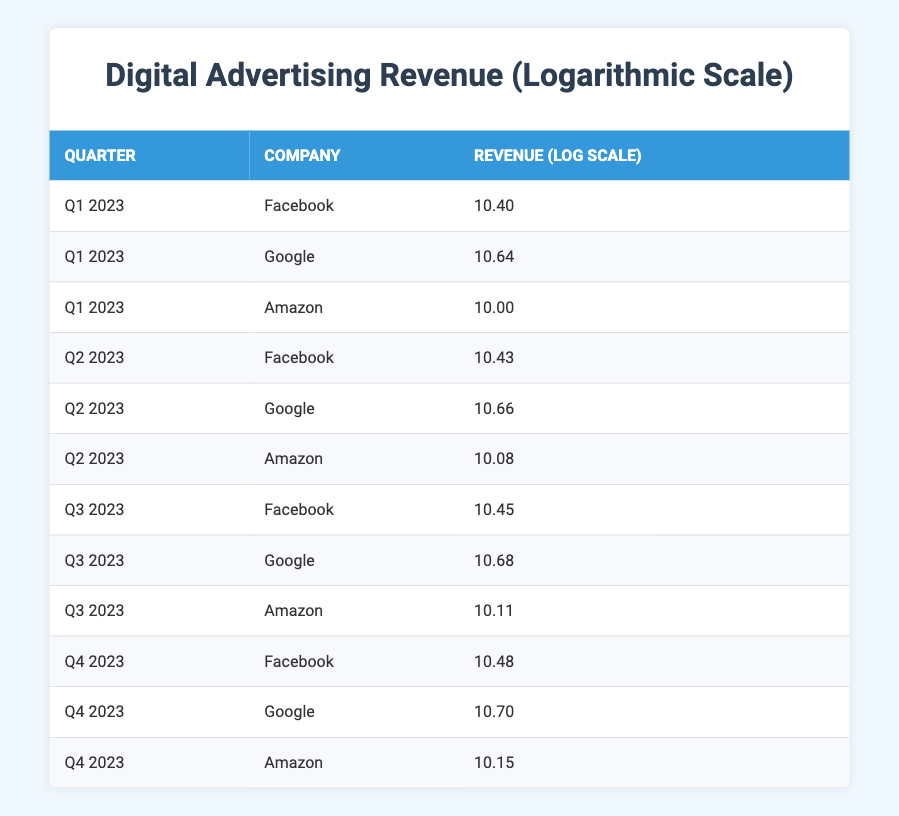What's the revenue generated by Google in Q1 2023? In the table, under the column for Q1 2023, the row corresponding to Google shows a revenue of 44000000000.
Answer: 44000000000 Which company had the highest logarithmic revenue in Q3 2023? Looking at the logarithmic revenue column for Q3 2023, Google has the highest value of 10.68, compared to Facebook (10.45) and Amazon (10.11).
Answer: Google What is the difference in logarithmic revenue between Facebook in Q4 2023 and Amazon in Q2 2023? Facebook’s logarithmic revenue for Q4 2023 is 10.48 and Amazon’s for Q2 2023 is 10.08. The difference is 10.48 - 10.08 = 0.40.
Answer: 0.40 Is Amazon's revenue higher in Q1 2023 or Q2 2023? In Q1 2023, Amazon's revenue is 10000000000, while in Q2 2023 it is 12000000000. Therefore, it is higher in Q2 2023.
Answer: Yes What is the average logarithmic revenue generated by Facebook across all quarters? The logarithmic revenues for Facebook across the four quarters are 10.40, 10.43, 10.45, and 10.48 respectively. The total is 10.40 + 10.43 + 10.45 + 10.48 = 41.76. Dividing by 4 gives an average of 41.76 / 4 = 10.44.
Answer: 10.44 How much revenue did Google generate in Q4 2023? The table shows that Google's revenue in Q4 2023 is 50000000000.
Answer: 50000000000 Which company had the smallest revenue in Q2 2023? In Q2 2023, Facebook generated 27000000000, Google generated 46000000000, and Amazon generated 12000000000. Amazon has the smallest revenue of 12000000000.
Answer: Amazon What was the total logarithmic revenue of all companies in Q1 2023 combined? Adding the logarithmic revenues of Facebook (10.40), Google (10.64), and Amazon (10.00) gives 10.40 + 10.64 + 10.00 = 31.04 for Q1 2023.
Answer: 31.04 How does Amazon's logarithmic revenue in Q3 2023 compare to its revenue in Q4 2023? Amazon's logarithmic revenue in Q3 2023 is 10.11 and in Q4 2023 it is 10.15. Q4 2023 shows higher revenue compared to Q3 2023 by 10.15 - 10.11 = 0.04.
Answer: Higher in Q4 2023 